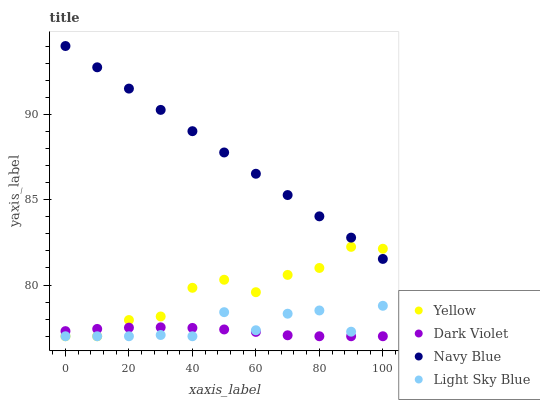Does Dark Violet have the minimum area under the curve?
Answer yes or no. Yes. Does Navy Blue have the maximum area under the curve?
Answer yes or no. Yes. Does Light Sky Blue have the minimum area under the curve?
Answer yes or no. No. Does Light Sky Blue have the maximum area under the curve?
Answer yes or no. No. Is Navy Blue the smoothest?
Answer yes or no. Yes. Is Light Sky Blue the roughest?
Answer yes or no. Yes. Is Dark Violet the smoothest?
Answer yes or no. No. Is Dark Violet the roughest?
Answer yes or no. No. Does Light Sky Blue have the lowest value?
Answer yes or no. Yes. Does Navy Blue have the highest value?
Answer yes or no. Yes. Does Light Sky Blue have the highest value?
Answer yes or no. No. Is Dark Violet less than Navy Blue?
Answer yes or no. Yes. Is Navy Blue greater than Dark Violet?
Answer yes or no. Yes. Does Dark Violet intersect Light Sky Blue?
Answer yes or no. Yes. Is Dark Violet less than Light Sky Blue?
Answer yes or no. No. Is Dark Violet greater than Light Sky Blue?
Answer yes or no. No. Does Dark Violet intersect Navy Blue?
Answer yes or no. No. 